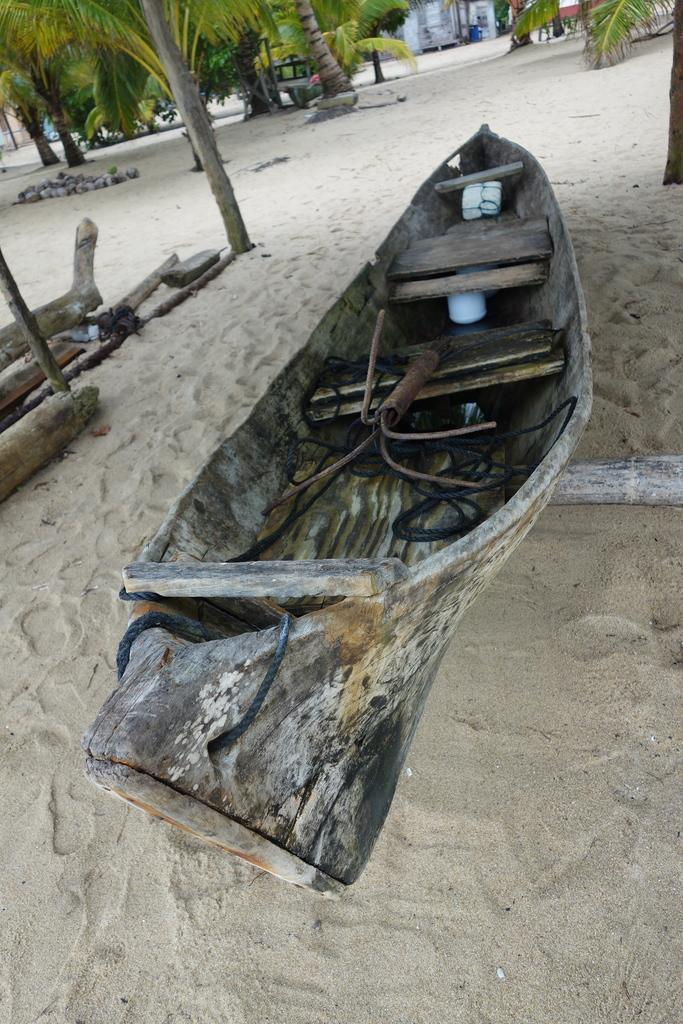What is the main object on the ground in the image? There is a boat on the ground in the image. What can be found on the boat? There are objects on the boat, including a rope. What type of objects can be seen in the image besides the boat? There are trunks, trees, and stones in the image. What type of structure is visible in the image? There is a house in the image. What appliance is being used to cook a meal in the image? There is no appliance or cooking activity visible in the image. Can you describe the romantic moment between the two people in the image? There are no people or romantic moments depicted in the image. 